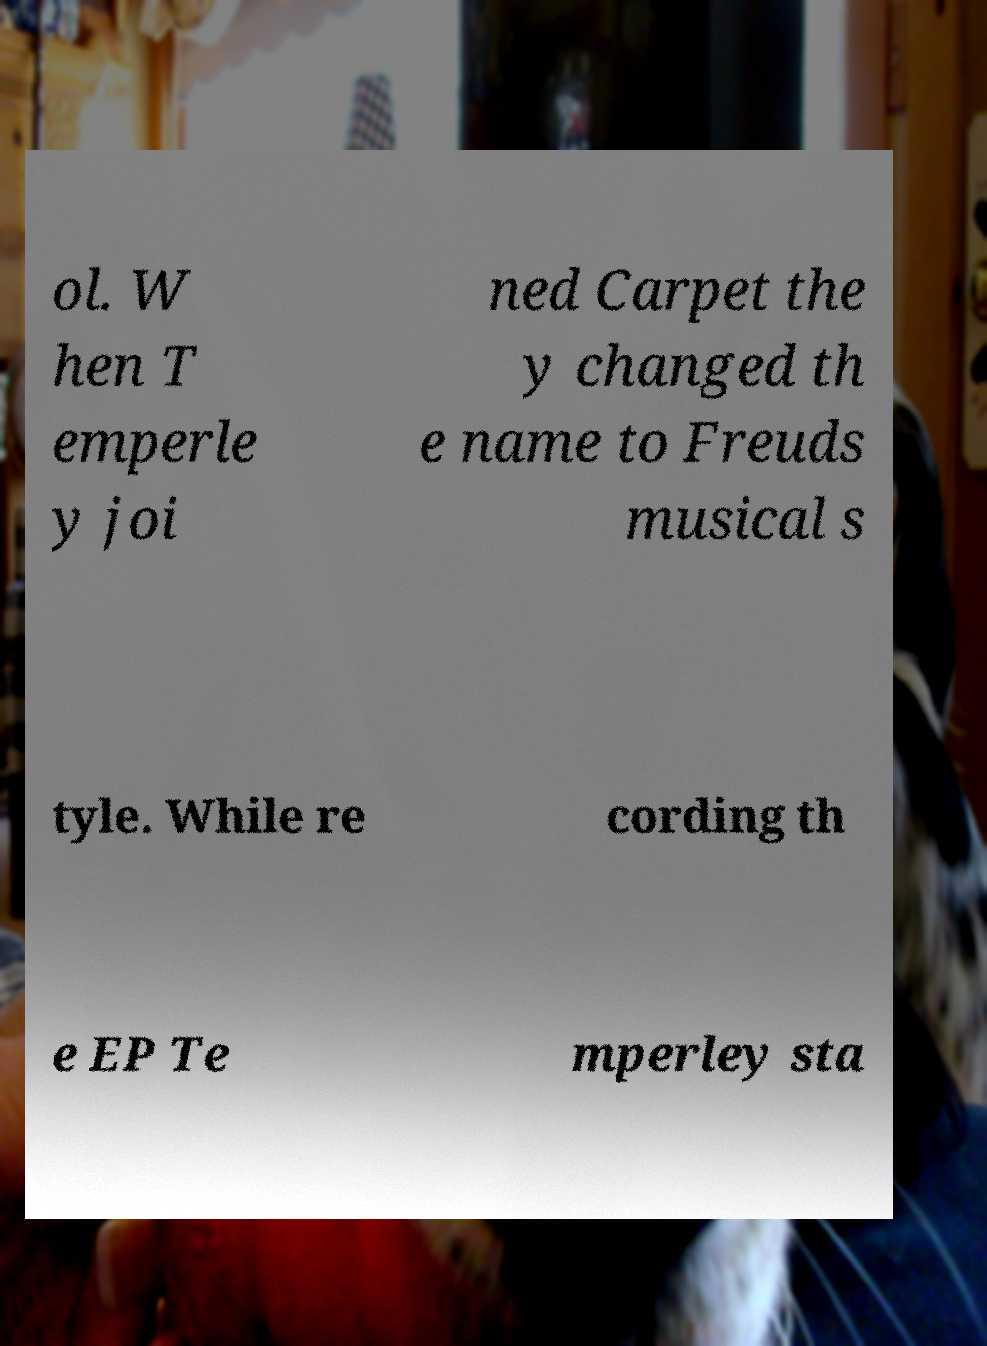Could you extract and type out the text from this image? ol. W hen T emperle y joi ned Carpet the y changed th e name to Freuds musical s tyle. While re cording th e EP Te mperley sta 